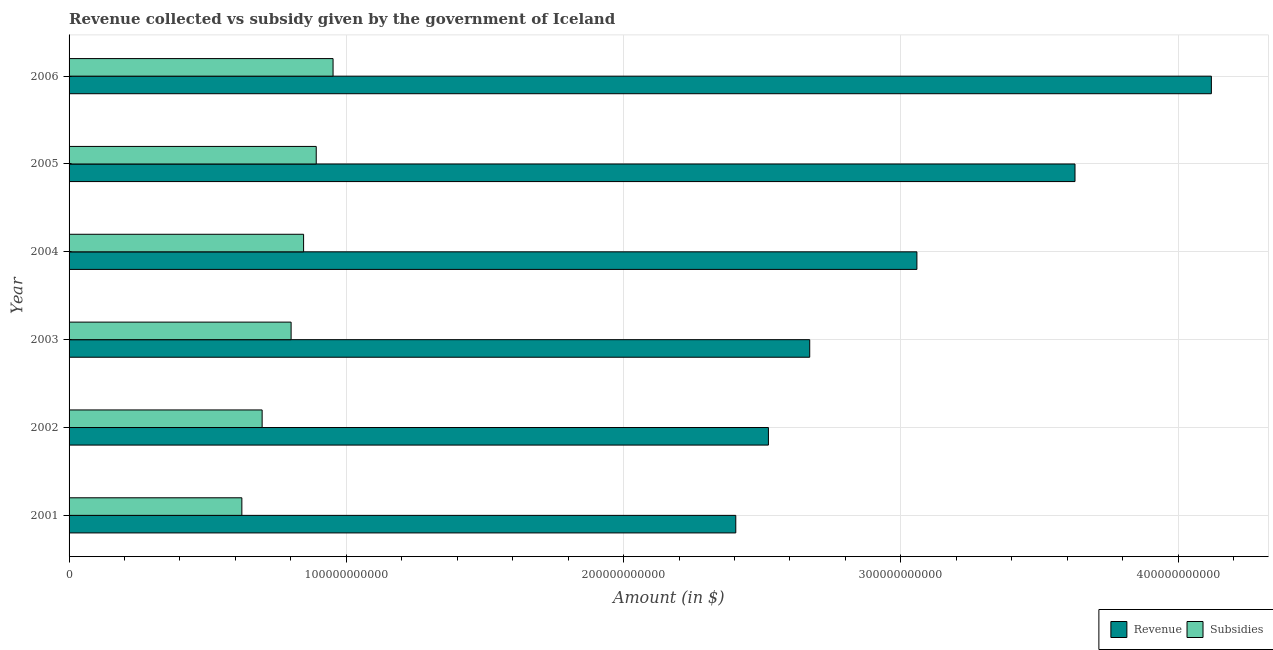How many different coloured bars are there?
Provide a succinct answer. 2. Are the number of bars on each tick of the Y-axis equal?
Make the answer very short. Yes. What is the label of the 3rd group of bars from the top?
Keep it short and to the point. 2004. What is the amount of revenue collected in 2001?
Offer a terse response. 2.40e+11. Across all years, what is the maximum amount of subsidies given?
Ensure brevity in your answer.  9.52e+1. Across all years, what is the minimum amount of subsidies given?
Offer a very short reply. 6.23e+1. What is the total amount of subsidies given in the graph?
Your answer should be very brief. 4.81e+11. What is the difference between the amount of revenue collected in 2003 and that in 2004?
Your response must be concise. -3.87e+1. What is the difference between the amount of revenue collected in 2006 and the amount of subsidies given in 2001?
Your answer should be compact. 3.50e+11. What is the average amount of revenue collected per year?
Provide a short and direct response. 3.07e+11. In the year 2002, what is the difference between the amount of subsidies given and amount of revenue collected?
Give a very brief answer. -1.83e+11. What is the ratio of the amount of revenue collected in 2004 to that in 2005?
Your answer should be compact. 0.84. Is the difference between the amount of subsidies given in 2001 and 2006 greater than the difference between the amount of revenue collected in 2001 and 2006?
Offer a very short reply. Yes. What is the difference between the highest and the second highest amount of subsidies given?
Make the answer very short. 6.07e+09. What is the difference between the highest and the lowest amount of revenue collected?
Your response must be concise. 1.72e+11. In how many years, is the amount of subsidies given greater than the average amount of subsidies given taken over all years?
Provide a succinct answer. 3. Is the sum of the amount of subsidies given in 2001 and 2002 greater than the maximum amount of revenue collected across all years?
Offer a terse response. No. What does the 1st bar from the top in 2001 represents?
Make the answer very short. Subsidies. What does the 2nd bar from the bottom in 2004 represents?
Your answer should be compact. Subsidies. Are all the bars in the graph horizontal?
Provide a short and direct response. Yes. What is the difference between two consecutive major ticks on the X-axis?
Your answer should be compact. 1.00e+11. Are the values on the major ticks of X-axis written in scientific E-notation?
Provide a short and direct response. No. What is the title of the graph?
Your answer should be compact. Revenue collected vs subsidy given by the government of Iceland. What is the label or title of the X-axis?
Keep it short and to the point. Amount (in $). What is the label or title of the Y-axis?
Offer a terse response. Year. What is the Amount (in $) in Revenue in 2001?
Your response must be concise. 2.40e+11. What is the Amount (in $) in Subsidies in 2001?
Provide a short and direct response. 6.23e+1. What is the Amount (in $) of Revenue in 2002?
Your response must be concise. 2.52e+11. What is the Amount (in $) in Subsidies in 2002?
Your response must be concise. 6.96e+1. What is the Amount (in $) of Revenue in 2003?
Your answer should be very brief. 2.67e+11. What is the Amount (in $) of Subsidies in 2003?
Offer a terse response. 8.01e+1. What is the Amount (in $) of Revenue in 2004?
Give a very brief answer. 3.06e+11. What is the Amount (in $) in Subsidies in 2004?
Provide a succinct answer. 8.46e+1. What is the Amount (in $) of Revenue in 2005?
Give a very brief answer. 3.63e+11. What is the Amount (in $) in Subsidies in 2005?
Provide a succinct answer. 8.92e+1. What is the Amount (in $) of Revenue in 2006?
Your response must be concise. 4.12e+11. What is the Amount (in $) in Subsidies in 2006?
Keep it short and to the point. 9.52e+1. Across all years, what is the maximum Amount (in $) in Revenue?
Provide a succinct answer. 4.12e+11. Across all years, what is the maximum Amount (in $) of Subsidies?
Make the answer very short. 9.52e+1. Across all years, what is the minimum Amount (in $) in Revenue?
Offer a very short reply. 2.40e+11. Across all years, what is the minimum Amount (in $) of Subsidies?
Your answer should be very brief. 6.23e+1. What is the total Amount (in $) of Revenue in the graph?
Your response must be concise. 1.84e+12. What is the total Amount (in $) of Subsidies in the graph?
Offer a terse response. 4.81e+11. What is the difference between the Amount (in $) in Revenue in 2001 and that in 2002?
Keep it short and to the point. -1.18e+1. What is the difference between the Amount (in $) in Subsidies in 2001 and that in 2002?
Your response must be concise. -7.32e+09. What is the difference between the Amount (in $) in Revenue in 2001 and that in 2003?
Provide a succinct answer. -2.67e+1. What is the difference between the Amount (in $) of Subsidies in 2001 and that in 2003?
Offer a very short reply. -1.78e+1. What is the difference between the Amount (in $) in Revenue in 2001 and that in 2004?
Give a very brief answer. -6.53e+1. What is the difference between the Amount (in $) in Subsidies in 2001 and that in 2004?
Provide a succinct answer. -2.23e+1. What is the difference between the Amount (in $) in Revenue in 2001 and that in 2005?
Ensure brevity in your answer.  -1.22e+11. What is the difference between the Amount (in $) in Subsidies in 2001 and that in 2005?
Give a very brief answer. -2.68e+1. What is the difference between the Amount (in $) in Revenue in 2001 and that in 2006?
Your answer should be very brief. -1.72e+11. What is the difference between the Amount (in $) in Subsidies in 2001 and that in 2006?
Your response must be concise. -3.29e+1. What is the difference between the Amount (in $) in Revenue in 2002 and that in 2003?
Ensure brevity in your answer.  -1.49e+1. What is the difference between the Amount (in $) in Subsidies in 2002 and that in 2003?
Make the answer very short. -1.05e+1. What is the difference between the Amount (in $) of Revenue in 2002 and that in 2004?
Offer a terse response. -5.36e+1. What is the difference between the Amount (in $) in Subsidies in 2002 and that in 2004?
Offer a very short reply. -1.50e+1. What is the difference between the Amount (in $) in Revenue in 2002 and that in 2005?
Your response must be concise. -1.11e+11. What is the difference between the Amount (in $) of Subsidies in 2002 and that in 2005?
Keep it short and to the point. -1.95e+1. What is the difference between the Amount (in $) of Revenue in 2002 and that in 2006?
Make the answer very short. -1.60e+11. What is the difference between the Amount (in $) of Subsidies in 2002 and that in 2006?
Give a very brief answer. -2.56e+1. What is the difference between the Amount (in $) in Revenue in 2003 and that in 2004?
Your response must be concise. -3.87e+1. What is the difference between the Amount (in $) of Subsidies in 2003 and that in 2004?
Your response must be concise. -4.50e+09. What is the difference between the Amount (in $) in Revenue in 2003 and that in 2005?
Make the answer very short. -9.57e+1. What is the difference between the Amount (in $) of Subsidies in 2003 and that in 2005?
Offer a very short reply. -9.06e+09. What is the difference between the Amount (in $) of Revenue in 2003 and that in 2006?
Give a very brief answer. -1.45e+11. What is the difference between the Amount (in $) of Subsidies in 2003 and that in 2006?
Make the answer very short. -1.51e+1. What is the difference between the Amount (in $) in Revenue in 2004 and that in 2005?
Offer a very short reply. -5.70e+1. What is the difference between the Amount (in $) in Subsidies in 2004 and that in 2005?
Offer a very short reply. -4.56e+09. What is the difference between the Amount (in $) of Revenue in 2004 and that in 2006?
Your response must be concise. -1.06e+11. What is the difference between the Amount (in $) in Subsidies in 2004 and that in 2006?
Offer a terse response. -1.06e+1. What is the difference between the Amount (in $) in Revenue in 2005 and that in 2006?
Your response must be concise. -4.92e+1. What is the difference between the Amount (in $) in Subsidies in 2005 and that in 2006?
Ensure brevity in your answer.  -6.07e+09. What is the difference between the Amount (in $) of Revenue in 2001 and the Amount (in $) of Subsidies in 2002?
Ensure brevity in your answer.  1.71e+11. What is the difference between the Amount (in $) in Revenue in 2001 and the Amount (in $) in Subsidies in 2003?
Ensure brevity in your answer.  1.60e+11. What is the difference between the Amount (in $) in Revenue in 2001 and the Amount (in $) in Subsidies in 2004?
Your answer should be compact. 1.56e+11. What is the difference between the Amount (in $) of Revenue in 2001 and the Amount (in $) of Subsidies in 2005?
Your response must be concise. 1.51e+11. What is the difference between the Amount (in $) of Revenue in 2001 and the Amount (in $) of Subsidies in 2006?
Provide a succinct answer. 1.45e+11. What is the difference between the Amount (in $) in Revenue in 2002 and the Amount (in $) in Subsidies in 2003?
Ensure brevity in your answer.  1.72e+11. What is the difference between the Amount (in $) of Revenue in 2002 and the Amount (in $) of Subsidies in 2004?
Your answer should be very brief. 1.68e+11. What is the difference between the Amount (in $) in Revenue in 2002 and the Amount (in $) in Subsidies in 2005?
Ensure brevity in your answer.  1.63e+11. What is the difference between the Amount (in $) of Revenue in 2002 and the Amount (in $) of Subsidies in 2006?
Keep it short and to the point. 1.57e+11. What is the difference between the Amount (in $) in Revenue in 2003 and the Amount (in $) in Subsidies in 2004?
Ensure brevity in your answer.  1.83e+11. What is the difference between the Amount (in $) of Revenue in 2003 and the Amount (in $) of Subsidies in 2005?
Provide a short and direct response. 1.78e+11. What is the difference between the Amount (in $) of Revenue in 2003 and the Amount (in $) of Subsidies in 2006?
Make the answer very short. 1.72e+11. What is the difference between the Amount (in $) of Revenue in 2004 and the Amount (in $) of Subsidies in 2005?
Your answer should be very brief. 2.17e+11. What is the difference between the Amount (in $) of Revenue in 2004 and the Amount (in $) of Subsidies in 2006?
Keep it short and to the point. 2.11e+11. What is the difference between the Amount (in $) in Revenue in 2005 and the Amount (in $) in Subsidies in 2006?
Give a very brief answer. 2.68e+11. What is the average Amount (in $) in Revenue per year?
Your response must be concise. 3.07e+11. What is the average Amount (in $) in Subsidies per year?
Offer a very short reply. 8.02e+1. In the year 2001, what is the difference between the Amount (in $) of Revenue and Amount (in $) of Subsidies?
Make the answer very short. 1.78e+11. In the year 2002, what is the difference between the Amount (in $) of Revenue and Amount (in $) of Subsidies?
Your answer should be compact. 1.83e+11. In the year 2003, what is the difference between the Amount (in $) in Revenue and Amount (in $) in Subsidies?
Offer a terse response. 1.87e+11. In the year 2004, what is the difference between the Amount (in $) of Revenue and Amount (in $) of Subsidies?
Your answer should be very brief. 2.21e+11. In the year 2005, what is the difference between the Amount (in $) of Revenue and Amount (in $) of Subsidies?
Your answer should be compact. 2.74e+11. In the year 2006, what is the difference between the Amount (in $) of Revenue and Amount (in $) of Subsidies?
Keep it short and to the point. 3.17e+11. What is the ratio of the Amount (in $) in Revenue in 2001 to that in 2002?
Provide a succinct answer. 0.95. What is the ratio of the Amount (in $) of Subsidies in 2001 to that in 2002?
Offer a very short reply. 0.89. What is the ratio of the Amount (in $) of Revenue in 2001 to that in 2003?
Your answer should be compact. 0.9. What is the ratio of the Amount (in $) in Subsidies in 2001 to that in 2003?
Your response must be concise. 0.78. What is the ratio of the Amount (in $) of Revenue in 2001 to that in 2004?
Provide a succinct answer. 0.79. What is the ratio of the Amount (in $) of Subsidies in 2001 to that in 2004?
Offer a terse response. 0.74. What is the ratio of the Amount (in $) of Revenue in 2001 to that in 2005?
Offer a very short reply. 0.66. What is the ratio of the Amount (in $) of Subsidies in 2001 to that in 2005?
Ensure brevity in your answer.  0.7. What is the ratio of the Amount (in $) of Revenue in 2001 to that in 2006?
Give a very brief answer. 0.58. What is the ratio of the Amount (in $) of Subsidies in 2001 to that in 2006?
Your response must be concise. 0.65. What is the ratio of the Amount (in $) in Revenue in 2002 to that in 2003?
Ensure brevity in your answer.  0.94. What is the ratio of the Amount (in $) in Subsidies in 2002 to that in 2003?
Your answer should be compact. 0.87. What is the ratio of the Amount (in $) in Revenue in 2002 to that in 2004?
Keep it short and to the point. 0.82. What is the ratio of the Amount (in $) of Subsidies in 2002 to that in 2004?
Make the answer very short. 0.82. What is the ratio of the Amount (in $) of Revenue in 2002 to that in 2005?
Offer a terse response. 0.7. What is the ratio of the Amount (in $) in Subsidies in 2002 to that in 2005?
Provide a succinct answer. 0.78. What is the ratio of the Amount (in $) of Revenue in 2002 to that in 2006?
Make the answer very short. 0.61. What is the ratio of the Amount (in $) of Subsidies in 2002 to that in 2006?
Provide a succinct answer. 0.73. What is the ratio of the Amount (in $) in Revenue in 2003 to that in 2004?
Make the answer very short. 0.87. What is the ratio of the Amount (in $) in Subsidies in 2003 to that in 2004?
Your answer should be very brief. 0.95. What is the ratio of the Amount (in $) of Revenue in 2003 to that in 2005?
Provide a succinct answer. 0.74. What is the ratio of the Amount (in $) of Subsidies in 2003 to that in 2005?
Provide a succinct answer. 0.9. What is the ratio of the Amount (in $) of Revenue in 2003 to that in 2006?
Provide a succinct answer. 0.65. What is the ratio of the Amount (in $) in Subsidies in 2003 to that in 2006?
Provide a succinct answer. 0.84. What is the ratio of the Amount (in $) of Revenue in 2004 to that in 2005?
Provide a short and direct response. 0.84. What is the ratio of the Amount (in $) in Subsidies in 2004 to that in 2005?
Offer a terse response. 0.95. What is the ratio of the Amount (in $) in Revenue in 2004 to that in 2006?
Your response must be concise. 0.74. What is the ratio of the Amount (in $) of Subsidies in 2004 to that in 2006?
Provide a short and direct response. 0.89. What is the ratio of the Amount (in $) of Revenue in 2005 to that in 2006?
Make the answer very short. 0.88. What is the ratio of the Amount (in $) of Subsidies in 2005 to that in 2006?
Keep it short and to the point. 0.94. What is the difference between the highest and the second highest Amount (in $) in Revenue?
Offer a very short reply. 4.92e+1. What is the difference between the highest and the second highest Amount (in $) in Subsidies?
Ensure brevity in your answer.  6.07e+09. What is the difference between the highest and the lowest Amount (in $) of Revenue?
Provide a short and direct response. 1.72e+11. What is the difference between the highest and the lowest Amount (in $) of Subsidies?
Ensure brevity in your answer.  3.29e+1. 